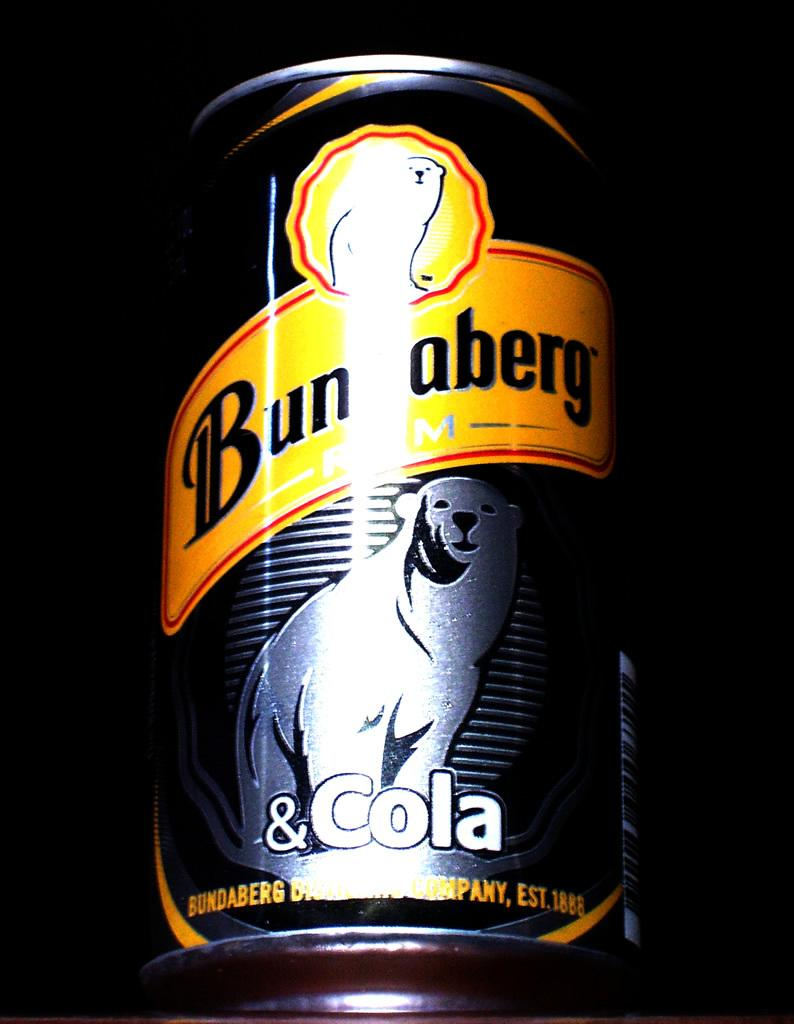<image>
Write a terse but informative summary of the picture. A polar bear is on a can of Bunaberg cola. 